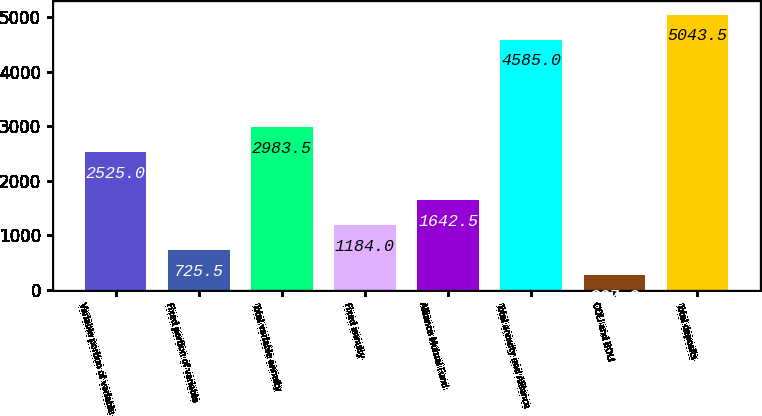<chart> <loc_0><loc_0><loc_500><loc_500><bar_chart><fcel>Variable portion of variable<fcel>Fixed portion of variable<fcel>Total variable annuity<fcel>Fixed annuity<fcel>Alliance Mutual Fund<fcel>Total annuity and Alliance<fcel>COLI and BOLI<fcel>Total deposits<nl><fcel>2525<fcel>725.5<fcel>2983.5<fcel>1184<fcel>1642.5<fcel>4585<fcel>267<fcel>5043.5<nl></chart> 